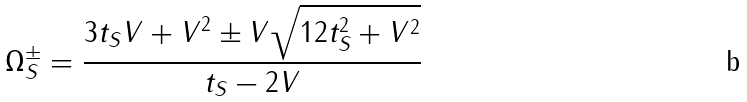Convert formula to latex. <formula><loc_0><loc_0><loc_500><loc_500>\Omega ^ { \pm } _ { S } = \frac { 3 t _ { S } V + V ^ { 2 } \pm V \sqrt { 1 2 t _ { S } ^ { 2 } + V ^ { 2 } } } { t _ { S } - 2 V }</formula> 